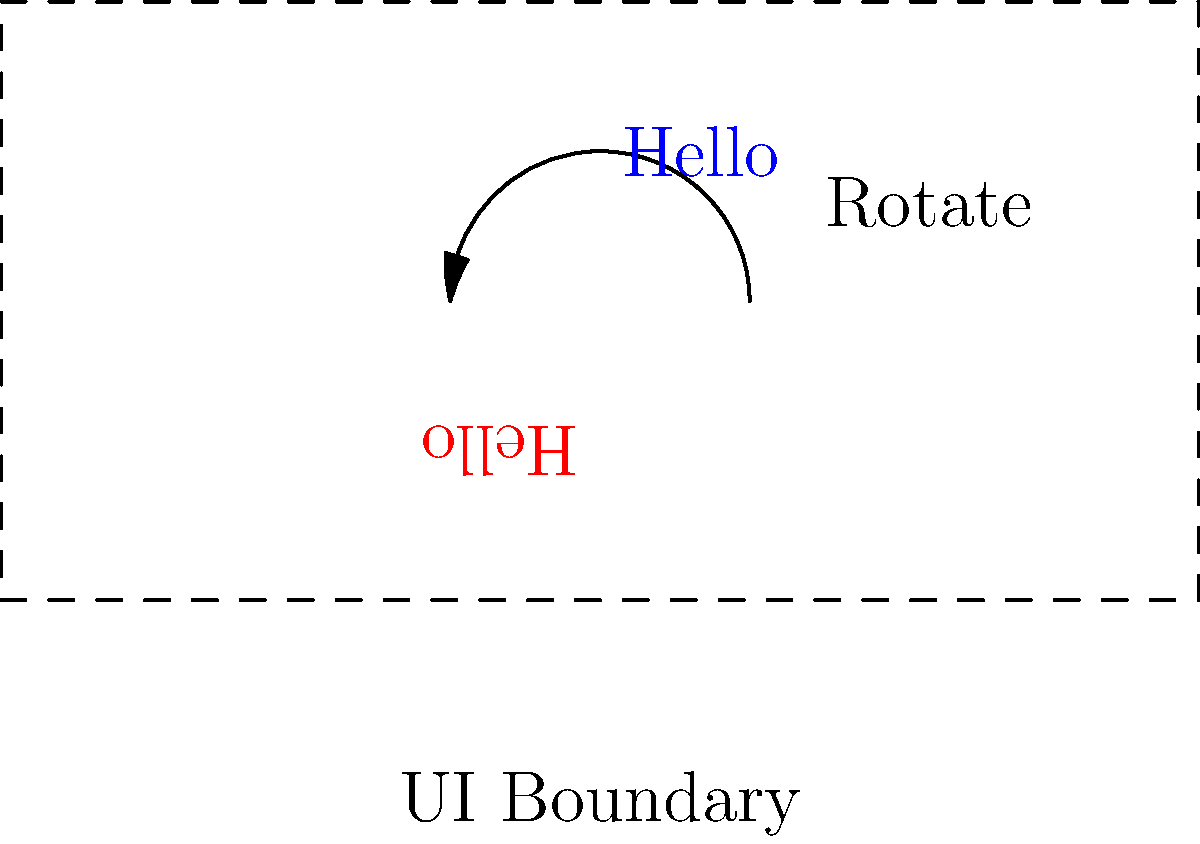In implementing a translation interface that supports right-to-left languages using the Google Translate API, you need to rotate the text orientation by 180 degrees. If the original text coordinates are $(x, y)$, what would be the formula for the new coordinates $(x', y')$ after rotation? To rotate a point $(x, y)$ by 180 degrees around the origin, we can follow these steps:

1. Recall the general rotation matrix for a counterclockwise rotation by angle $\theta$:
   $$\begin{bmatrix} \cos\theta & -\sin\theta \\ \sin\theta & \cos\theta \end{bmatrix}$$

2. For a 180-degree rotation, $\theta = \pi$ radians. Therefore:
   $\cos\theta = \cos\pi = -1$
   $\sin\theta = \sin\pi = 0$

3. Substituting these values into the rotation matrix:
   $$\begin{bmatrix} -1 & 0 \\ 0 & -1 \end{bmatrix}$$

4. Apply this matrix to the original coordinates:
   $$\begin{bmatrix} x' \\ y' \end{bmatrix} = \begin{bmatrix} -1 & 0 \\ 0 & -1 \end{bmatrix} \begin{bmatrix} x \\ y \end{bmatrix}$$

5. Multiplying the matrices:
   $$\begin{bmatrix} x' \\ y' \end{bmatrix} = \begin{bmatrix} -x \\ -y \end{bmatrix}$$

Therefore, the formula for the new coordinates after a 180-degree rotation is:
$x' = -x$ and $y' = -y$
Answer: $(x', y') = (-x, -y)$ 